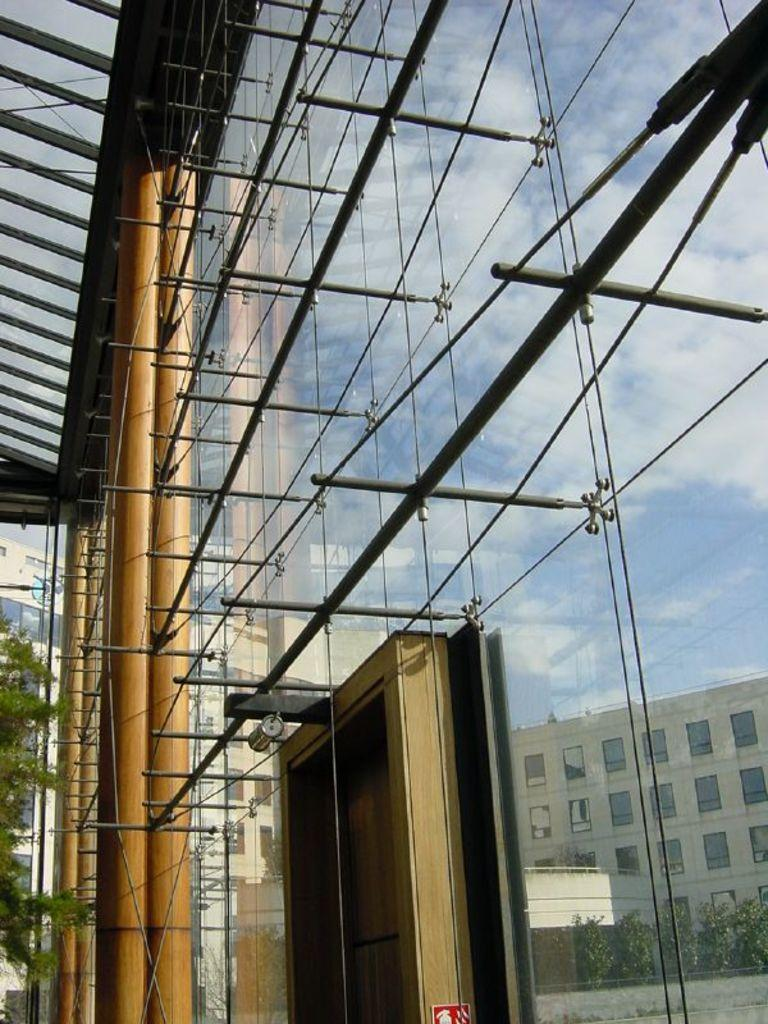What type of building is in the image? There is a glass building in the image. What color are the pillars in the image? The pillars in the image are brown-colored. What can be seen in the background of the image? There are trees in the background of the image, and they are green. What colors are visible in the sky in the image? The sky is visible in the image, and it is blue and white. What advice can be given to the trees in the image? There is no need to give advice to the trees in the image, as they are not sentient beings capable of understanding or following advice. 